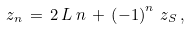<formula> <loc_0><loc_0><loc_500><loc_500>z _ { n } \, = \, 2 \, L \, n \, + \, \left ( - 1 \right ) ^ { n } \, z _ { S } \, ,</formula> 